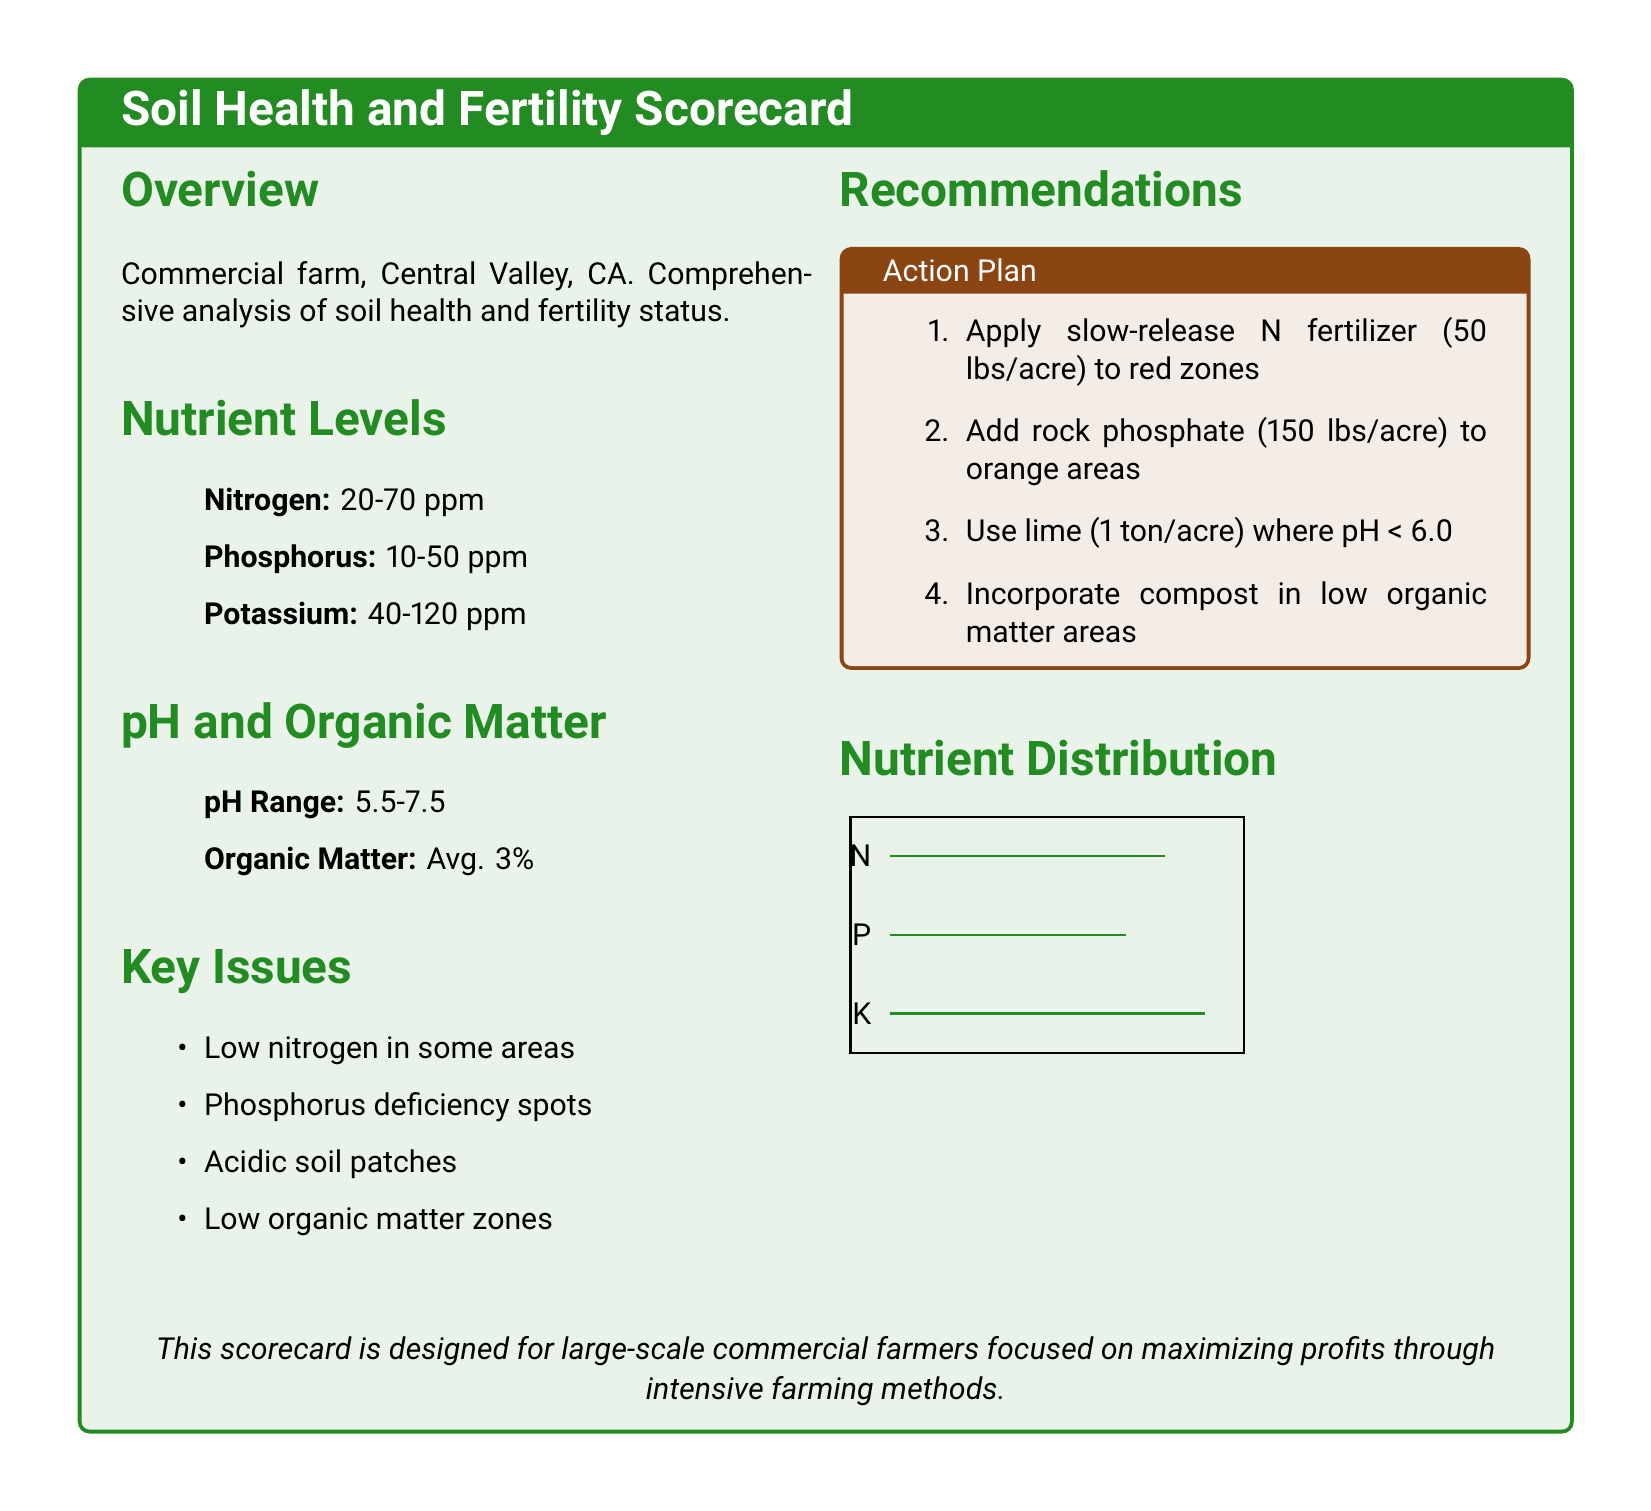What is the average organic matter content? The average organic matter content is explicitly listed in the document as an important parameter of soil health.
Answer: 3% What is the pH range of the soil? The pH range is provided in the section on pH and organic matter to assess soil acidity and alkalinity.
Answer: 5.5-7.5 What should be applied to red zones? The recommendations section specifies what amendments should be made to improve nutrient levels in deficient areas, focusing on red zones.
Answer: Slow-release N fertilizer (50 lbs/acre) What deficiency is noted for phosphorus? Key issues in the document highlight specific problems related to nutrient availability in the soil, particularly for phosphorus.
Answer: Phosphorus deficiency spots How much rock phosphate is recommended for orange areas? The action plan provides concrete numbers in terms of amounts for specific nutrient amendments targeted at improving soil health.
Answer: 150 lbs/acre What is the nitrogen level range in the soil? The nutrient levels section includes specific ranges for key nutrients in the soil, allowing quick assessment of nitrogen availability.
Answer: 20-70 ppm What is a recommended action for areas where pH is less than 6.0? Recommendations detail actions to be taken based on pH measurements to rectify soil quality issues.
Answer: Use lime (1 ton/acre) Which nutrient is the lowest in some areas? The key issues section highlights specific nutrient deficiencies, thus identifying which nutrients need immediate attention.
Answer: Nitrogen What does the nutrient distribution chart indicate for potassium? A visual representation in the scorecard might help to understand the distribution of nutrients, but specific comparisons can be drawn from the numbers.
Answer: K 